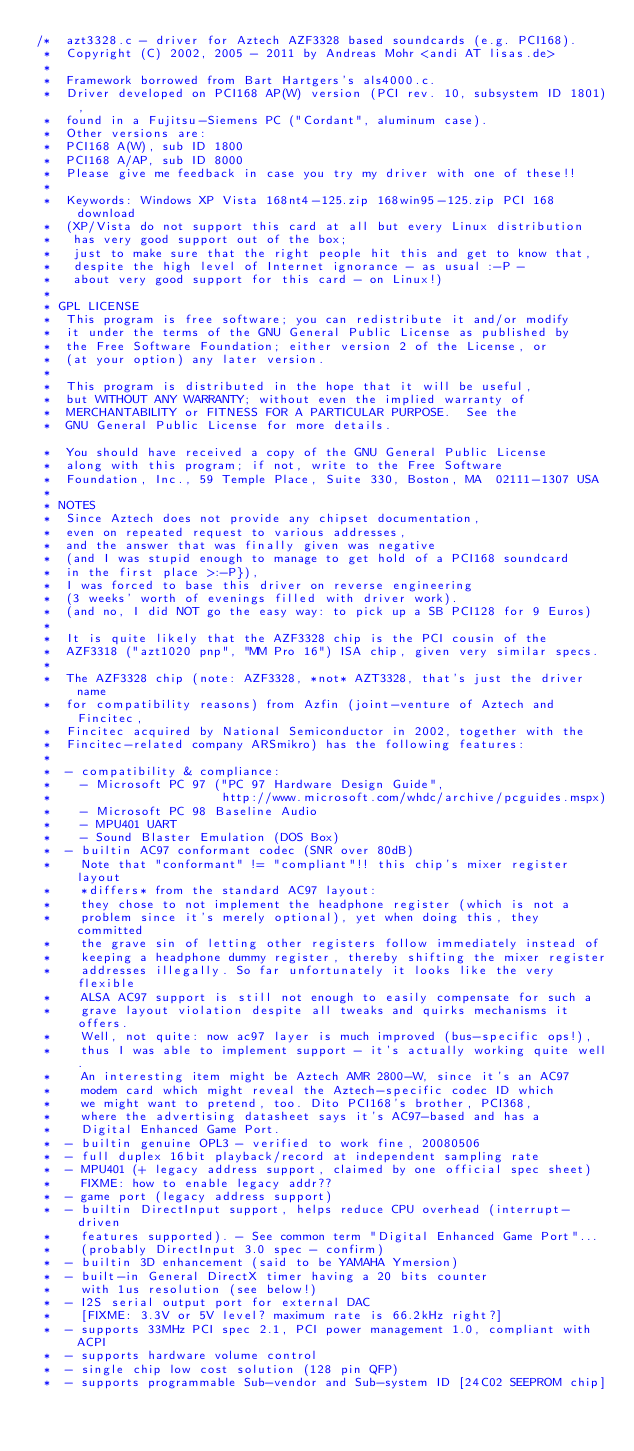Convert code to text. <code><loc_0><loc_0><loc_500><loc_500><_C_>/*  azt3328.c - driver for Aztech AZF3328 based soundcards (e.g. PCI168).
 *  Copyright (C) 2002, 2005 - 2011 by Andreas Mohr <andi AT lisas.de>
 *
 *  Framework borrowed from Bart Hartgers's als4000.c.
 *  Driver developed on PCI168 AP(W) version (PCI rev. 10, subsystem ID 1801),
 *  found in a Fujitsu-Siemens PC ("Cordant", aluminum case).
 *  Other versions are:
 *  PCI168 A(W), sub ID 1800
 *  PCI168 A/AP, sub ID 8000
 *  Please give me feedback in case you try my driver with one of these!!
 *
 *  Keywords: Windows XP Vista 168nt4-125.zip 168win95-125.zip PCI 168 download
 *  (XP/Vista do not support this card at all but every Linux distribution
 *   has very good support out of the box;
 *   just to make sure that the right people hit this and get to know that,
 *   despite the high level of Internet ignorance - as usual :-P -
 *   about very good support for this card - on Linux!)
 *
 * GPL LICENSE
 *  This program is free software; you can redistribute it and/or modify
 *  it under the terms of the GNU General Public License as published by
 *  the Free Software Foundation; either version 2 of the License, or
 *  (at your option) any later version.
 *
 *  This program is distributed in the hope that it will be useful,
 *  but WITHOUT ANY WARRANTY; without even the implied warranty of
 *  MERCHANTABILITY or FITNESS FOR A PARTICULAR PURPOSE.  See the
 *  GNU General Public License for more details.

 *  You should have received a copy of the GNU General Public License
 *  along with this program; if not, write to the Free Software
 *  Foundation, Inc., 59 Temple Place, Suite 330, Boston, MA  02111-1307 USA
 *
 * NOTES
 *  Since Aztech does not provide any chipset documentation,
 *  even on repeated request to various addresses,
 *  and the answer that was finally given was negative
 *  (and I was stupid enough to manage to get hold of a PCI168 soundcard
 *  in the first place >:-P}),
 *  I was forced to base this driver on reverse engineering
 *  (3 weeks' worth of evenings filled with driver work).
 *  (and no, I did NOT go the easy way: to pick up a SB PCI128 for 9 Euros)
 *
 *  It is quite likely that the AZF3328 chip is the PCI cousin of the
 *  AZF3318 ("azt1020 pnp", "MM Pro 16") ISA chip, given very similar specs.
 *
 *  The AZF3328 chip (note: AZF3328, *not* AZT3328, that's just the driver name
 *  for compatibility reasons) from Azfin (joint-venture of Aztech and Fincitec,
 *  Fincitec acquired by National Semiconductor in 2002, together with the
 *  Fincitec-related company ARSmikro) has the following features:
 *
 *  - compatibility & compliance:
 *    - Microsoft PC 97 ("PC 97 Hardware Design Guide",
 *                       http://www.microsoft.com/whdc/archive/pcguides.mspx)
 *    - Microsoft PC 98 Baseline Audio
 *    - MPU401 UART
 *    - Sound Blaster Emulation (DOS Box)
 *  - builtin AC97 conformant codec (SNR over 80dB)
 *    Note that "conformant" != "compliant"!! this chip's mixer register layout
 *    *differs* from the standard AC97 layout:
 *    they chose to not implement the headphone register (which is not a
 *    problem since it's merely optional), yet when doing this, they committed
 *    the grave sin of letting other registers follow immediately instead of
 *    keeping a headphone dummy register, thereby shifting the mixer register
 *    addresses illegally. So far unfortunately it looks like the very flexible
 *    ALSA AC97 support is still not enough to easily compensate for such a
 *    grave layout violation despite all tweaks and quirks mechanisms it offers.
 *    Well, not quite: now ac97 layer is much improved (bus-specific ops!),
 *    thus I was able to implement support - it's actually working quite well.
 *    An interesting item might be Aztech AMR 2800-W, since it's an AC97
 *    modem card which might reveal the Aztech-specific codec ID which
 *    we might want to pretend, too. Dito PCI168's brother, PCI368,
 *    where the advertising datasheet says it's AC97-based and has a
 *    Digital Enhanced Game Port.
 *  - builtin genuine OPL3 - verified to work fine, 20080506
 *  - full duplex 16bit playback/record at independent sampling rate
 *  - MPU401 (+ legacy address support, claimed by one official spec sheet)
 *    FIXME: how to enable legacy addr??
 *  - game port (legacy address support)
 *  - builtin DirectInput support, helps reduce CPU overhead (interrupt-driven
 *    features supported). - See common term "Digital Enhanced Game Port"...
 *    (probably DirectInput 3.0 spec - confirm)
 *  - builtin 3D enhancement (said to be YAMAHA Ymersion)
 *  - built-in General DirectX timer having a 20 bits counter
 *    with 1us resolution (see below!)
 *  - I2S serial output port for external DAC
 *    [FIXME: 3.3V or 5V level? maximum rate is 66.2kHz right?]
 *  - supports 33MHz PCI spec 2.1, PCI power management 1.0, compliant with ACPI
 *  - supports hardware volume control
 *  - single chip low cost solution (128 pin QFP)
 *  - supports programmable Sub-vendor and Sub-system ID [24C02 SEEPROM chip]</code> 